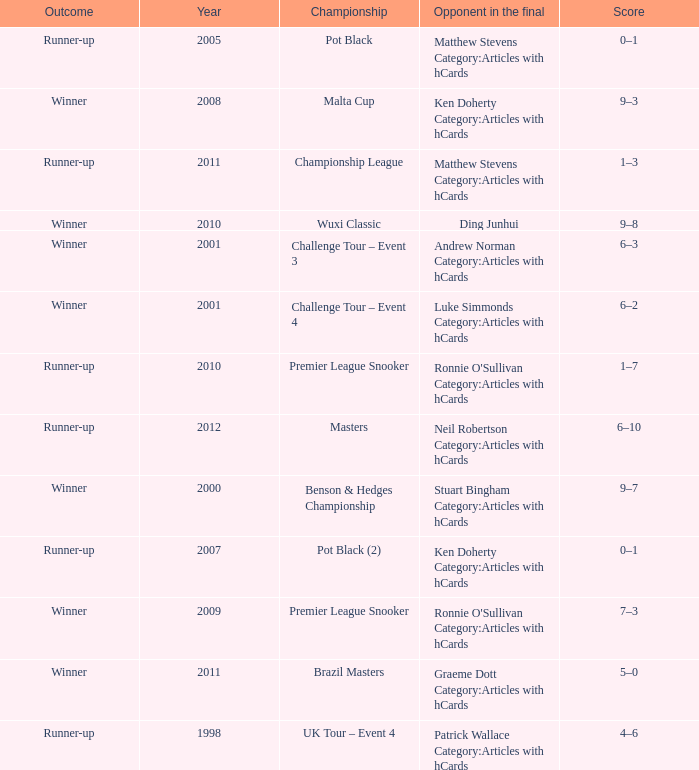Give me the full table as a dictionary. {'header': ['Outcome', 'Year', 'Championship', 'Opponent in the final', 'Score'], 'rows': [['Runner-up', '2005', 'Pot Black', 'Matthew Stevens Category:Articles with hCards', '0–1'], ['Winner', '2008', 'Malta Cup', 'Ken Doherty Category:Articles with hCards', '9–3'], ['Runner-up', '2011', 'Championship League', 'Matthew Stevens Category:Articles with hCards', '1–3'], ['Winner', '2010', 'Wuxi Classic', 'Ding Junhui', '9–8'], ['Winner', '2001', 'Challenge Tour – Event 3', 'Andrew Norman Category:Articles with hCards', '6–3'], ['Winner', '2001', 'Challenge Tour – Event 4', 'Luke Simmonds Category:Articles with hCards', '6–2'], ['Runner-up', '2010', 'Premier League Snooker', "Ronnie O'Sullivan Category:Articles with hCards", '1–7'], ['Runner-up', '2012', 'Masters', 'Neil Robertson Category:Articles with hCards', '6–10'], ['Winner', '2000', 'Benson & Hedges Championship', 'Stuart Bingham Category:Articles with hCards', '9–7'], ['Runner-up', '2007', 'Pot Black (2)', 'Ken Doherty Category:Articles with hCards', '0–1'], ['Winner', '2009', 'Premier League Snooker', "Ronnie O'Sullivan Category:Articles with hCards", '7–3'], ['Winner', '2011', 'Brazil Masters', 'Graeme Dott Category:Articles with hCards', '5–0'], ['Runner-up', '1998', 'UK Tour – Event 4', 'Patrick Wallace Category:Articles with hCards', '4–6']]} What was Shaun Murphy's outcome in the Premier League Snooker championship held before 2010? Winner. 